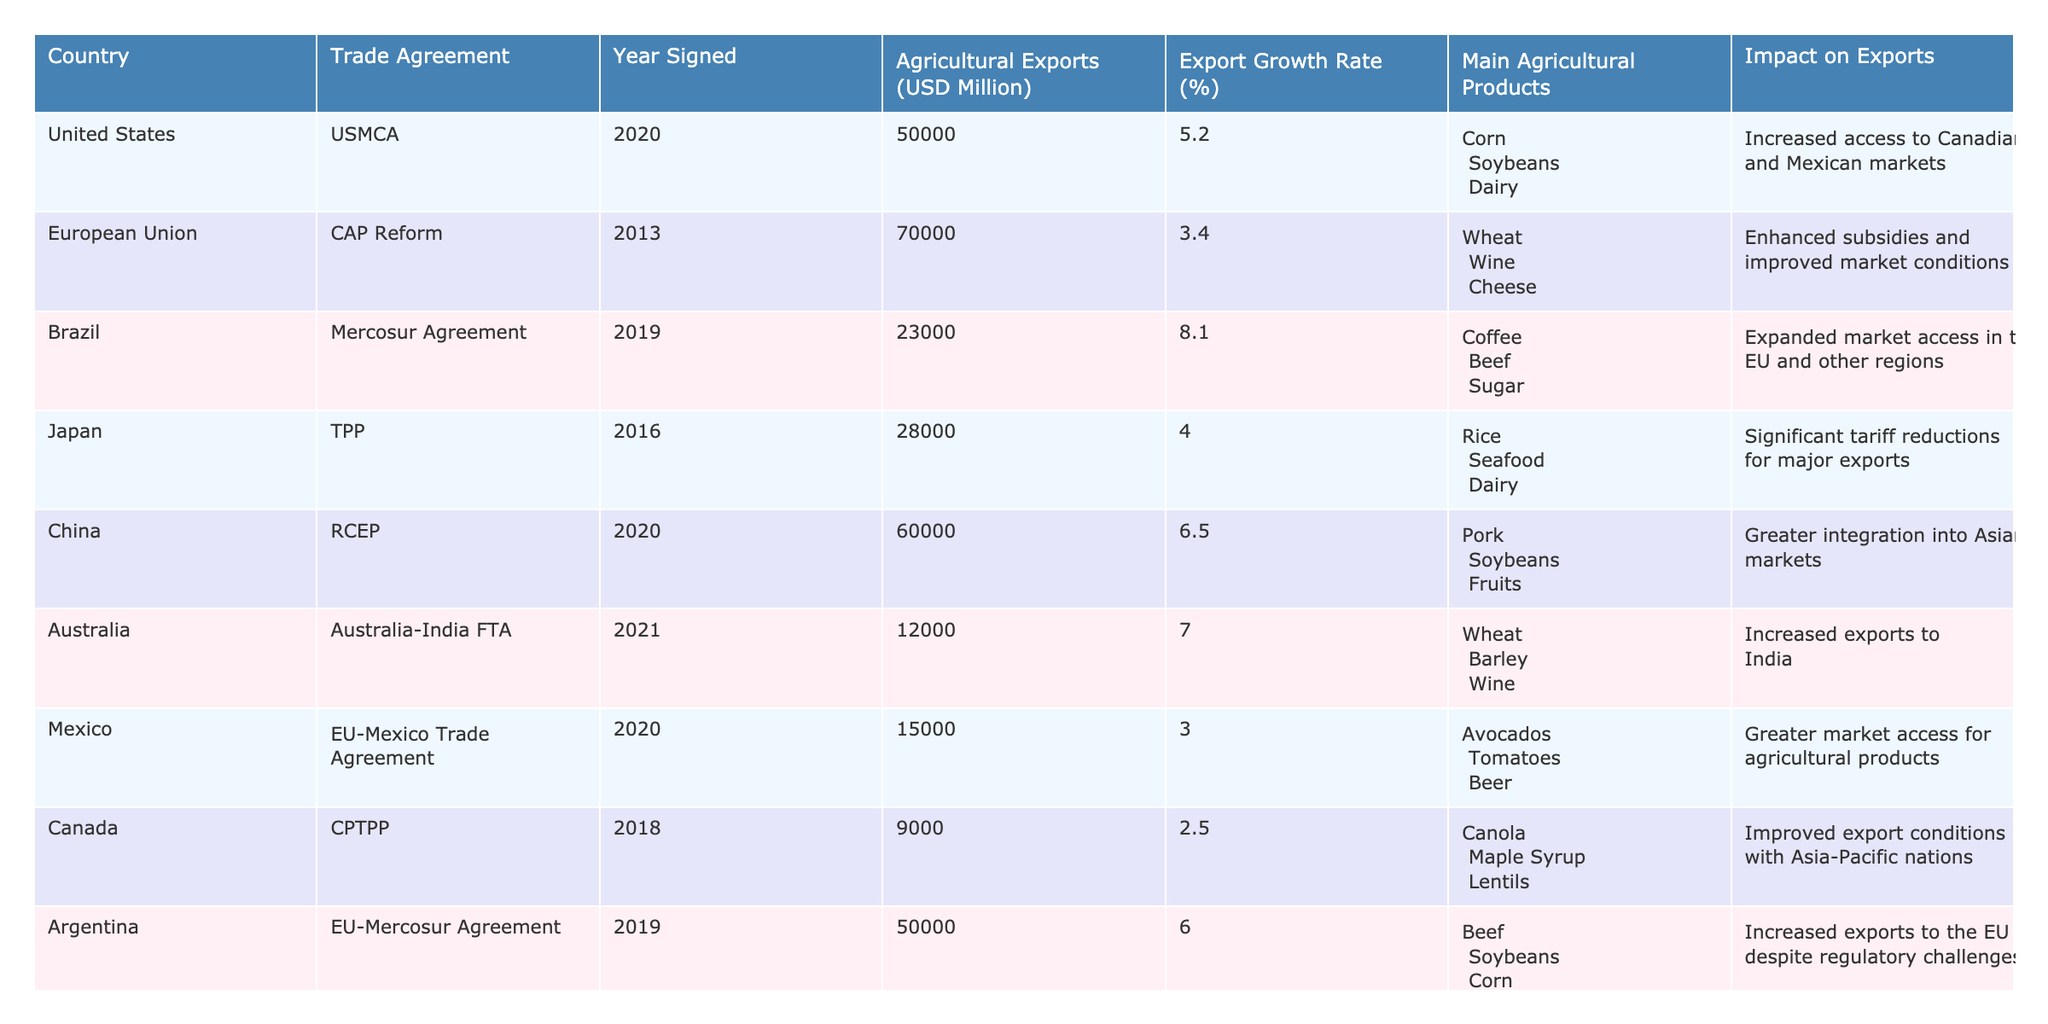What country has the highest agricultural exports? By reviewing the table, the United States has the highest agricultural exports at 50,000 million USD.
Answer: United States Which trade agreement was signed in 2020? The trade agreements signed in 2020 are USMCA (United States) and RCEP (China).
Answer: USMCA and RCEP What are the main agricultural products of Brazil? Brazil's main agricultural products are Coffee, Beef, and Sugar.
Answer: Coffee; Beef; Sugar What is the export growth rate for the European Union? The export growth rate for the European Union, according to the table, is 3.4%.
Answer: 3.4% True or false: Australia has a trade agreement with India that increased its agricultural exports. The table states that Australia signed the Australia-India FTA which led to increased exports to India, thus it is true.
Answer: True Which country experienced the highest export growth rate, and what was that rate? Brazil experienced the highest export growth rate of 8.1% as indicated in the table.
Answer: Brazil; 8.1% What is the average agricultural export value of the listed countries? The total agricultural exports sum up to 222,000 million USD across eight countries. By dividing by eight, the average is 27,750 million USD.
Answer: 27,750 million USD In which year was the CAP Reform signed, and how did it impact exports? CAP Reform was signed in 2013, and it enhanced subsidies and improved market conditions, leading to a positive impact on exports.
Answer: 2013; Enhanced subsidies and improved market conditions How do agricultural export values between Australia and Canada compare? Australia has agricultural exports worth 12,000 million USD, while Canada has 9,000 million USD. The difference is 3,000 million USD in favor of Australia.
Answer: Australia: 12,000 million USD; Canada: 9,000 million USD; Difference: 3,000 million USD Is there a trade agreement that significantly reduced tariffs for Japan? Yes, the TPP (Trans-Pacific Partnership) significantly reduced tariffs for Japan’s major exports.
Answer: Yes 